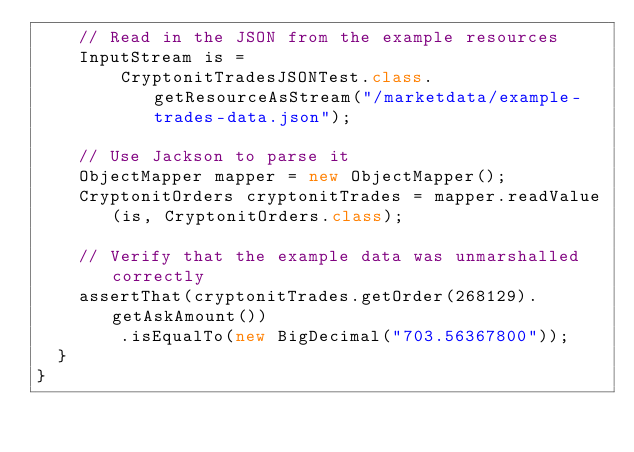Convert code to text. <code><loc_0><loc_0><loc_500><loc_500><_Java_>    // Read in the JSON from the example resources
    InputStream is =
        CryptonitTradesJSONTest.class.getResourceAsStream("/marketdata/example-trades-data.json");

    // Use Jackson to parse it
    ObjectMapper mapper = new ObjectMapper();
    CryptonitOrders cryptonitTrades = mapper.readValue(is, CryptonitOrders.class);

    // Verify that the example data was unmarshalled correctly
    assertThat(cryptonitTrades.getOrder(268129).getAskAmount())
        .isEqualTo(new BigDecimal("703.56367800"));
  }
}
</code> 